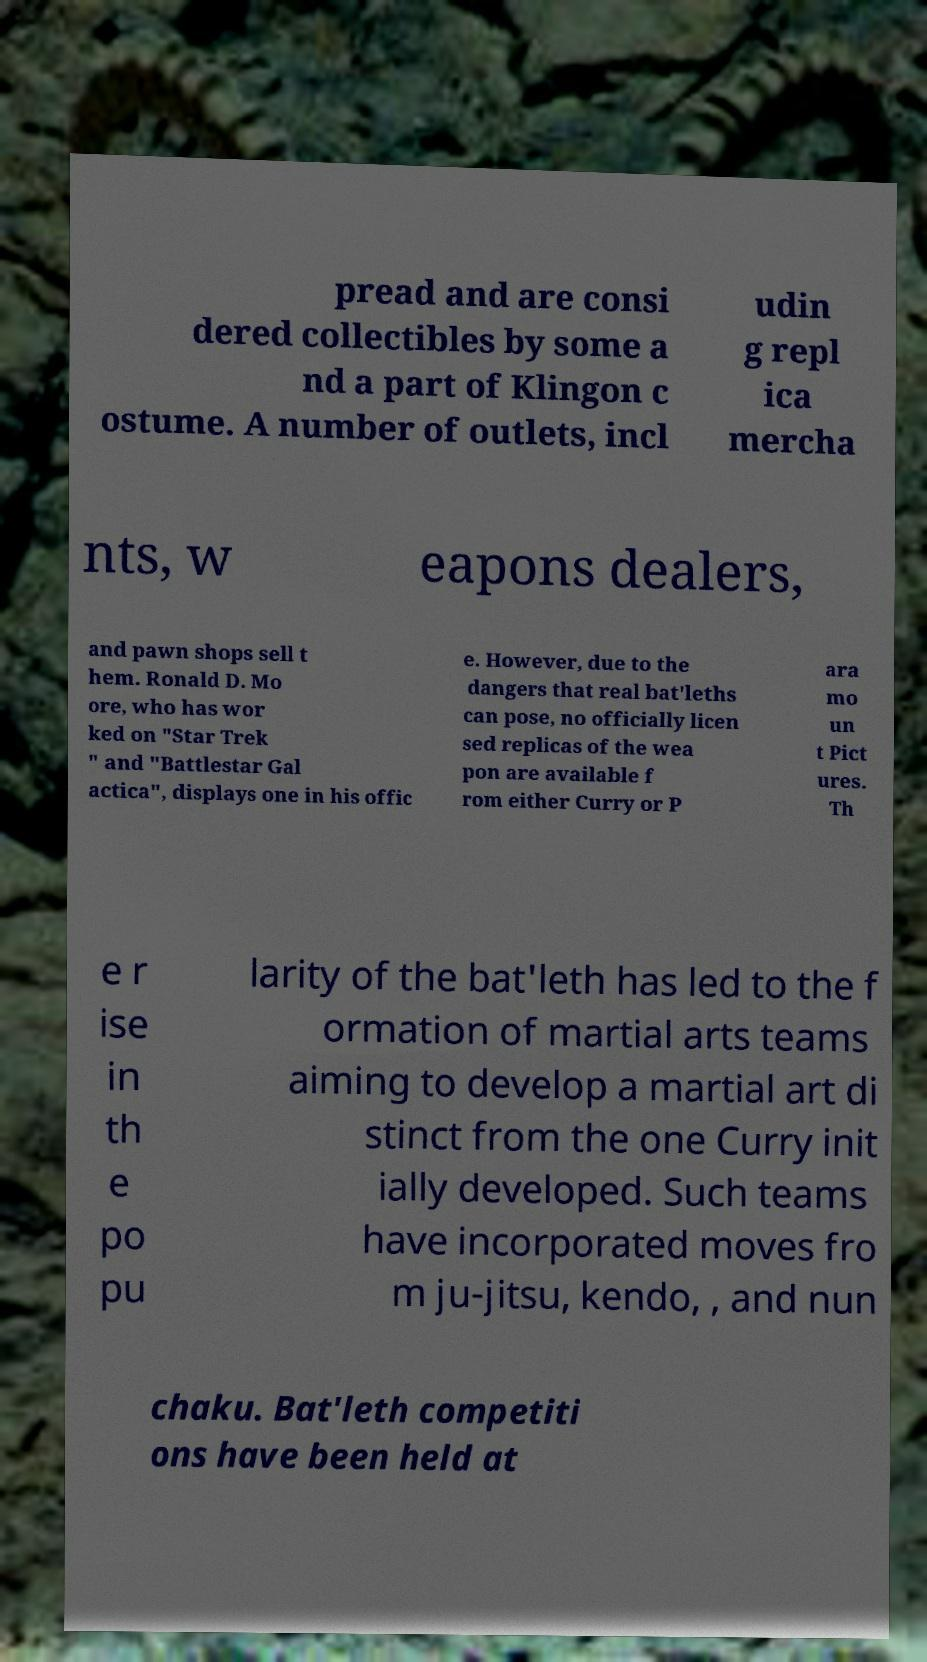For documentation purposes, I need the text within this image transcribed. Could you provide that? pread and are consi dered collectibles by some a nd a part of Klingon c ostume. A number of outlets, incl udin g repl ica mercha nts, w eapons dealers, and pawn shops sell t hem. Ronald D. Mo ore, who has wor ked on "Star Trek " and "Battlestar Gal actica", displays one in his offic e. However, due to the dangers that real bat'leths can pose, no officially licen sed replicas of the wea pon are available f rom either Curry or P ara mo un t Pict ures. Th e r ise in th e po pu larity of the bat'leth has led to the f ormation of martial arts teams aiming to develop a martial art di stinct from the one Curry init ially developed. Such teams have incorporated moves fro m ju-jitsu, kendo, , and nun chaku. Bat'leth competiti ons have been held at 